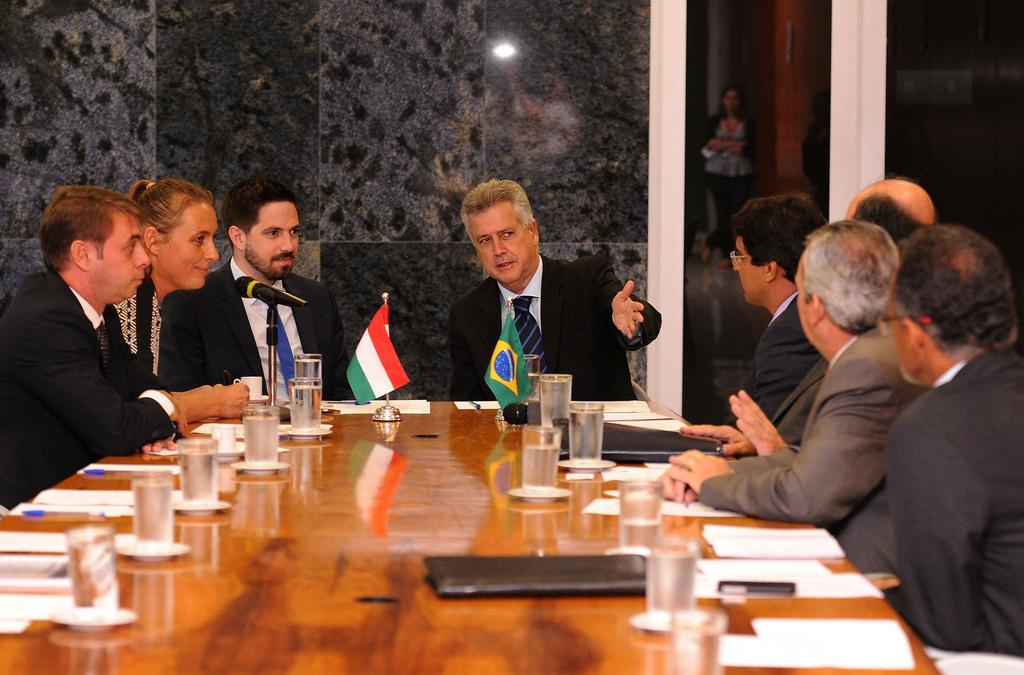How many people are sitting in the image? There are eight persons sitting on chairs. What is the main object in the center of the image? There is a table in the image. What can be seen on the table? Glasses are present on the table. What national symbols are visible in the image? There are two flags of different countries in the image. What is the average income of the people sitting in the image? There is no information about the income of the people in the image, so it cannot be determined. What type of humor is being displayed by the people in the image? There is no indication of humor in the image; the people are simply sitting and there are no expressions or actions suggesting humor. 